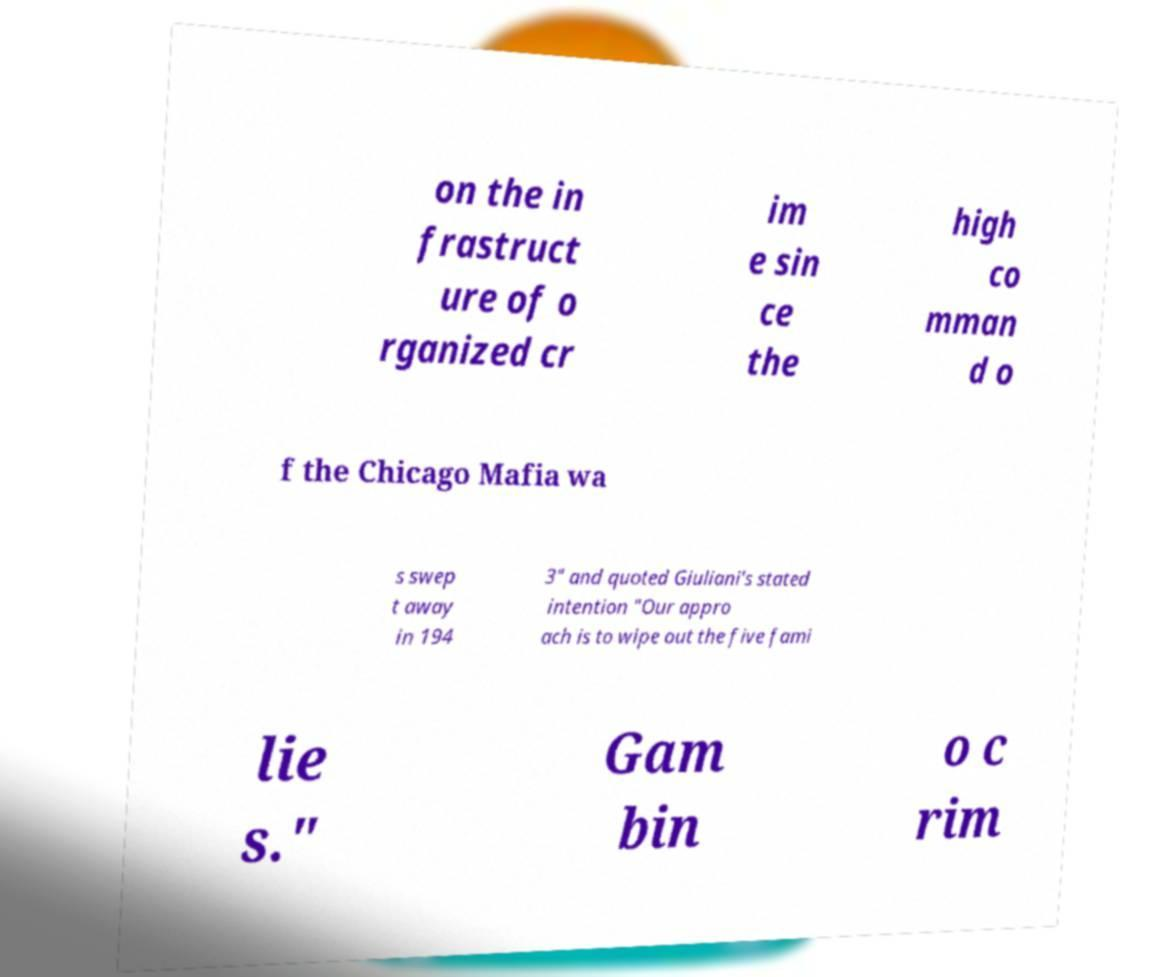Could you extract and type out the text from this image? on the in frastruct ure of o rganized cr im e sin ce the high co mman d o f the Chicago Mafia wa s swep t away in 194 3" and quoted Giuliani's stated intention "Our appro ach is to wipe out the five fami lie s." Gam bin o c rim 